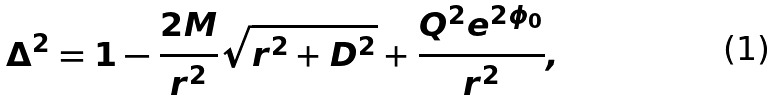Convert formula to latex. <formula><loc_0><loc_0><loc_500><loc_500>\Delta ^ { 2 } = 1 - \frac { 2 M } { r ^ { 2 } } \sqrt { r ^ { 2 } + D ^ { 2 } } + \frac { { Q ^ { 2 } e ^ { 2 \phi _ { 0 } } } } { r ^ { 2 } } ,</formula> 